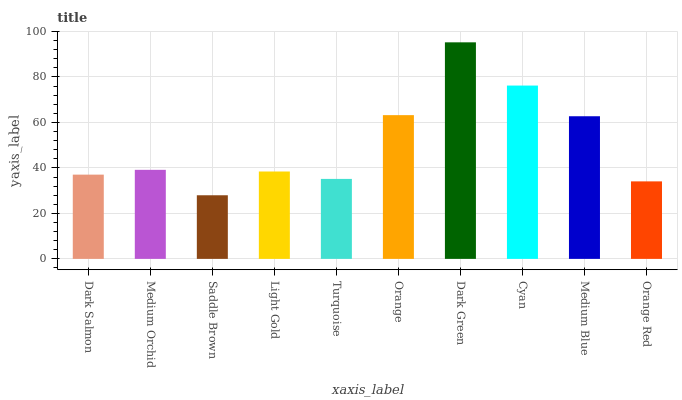Is Saddle Brown the minimum?
Answer yes or no. Yes. Is Dark Green the maximum?
Answer yes or no. Yes. Is Medium Orchid the minimum?
Answer yes or no. No. Is Medium Orchid the maximum?
Answer yes or no. No. Is Medium Orchid greater than Dark Salmon?
Answer yes or no. Yes. Is Dark Salmon less than Medium Orchid?
Answer yes or no. Yes. Is Dark Salmon greater than Medium Orchid?
Answer yes or no. No. Is Medium Orchid less than Dark Salmon?
Answer yes or no. No. Is Medium Orchid the high median?
Answer yes or no. Yes. Is Light Gold the low median?
Answer yes or no. Yes. Is Orange the high median?
Answer yes or no. No. Is Dark Green the low median?
Answer yes or no. No. 